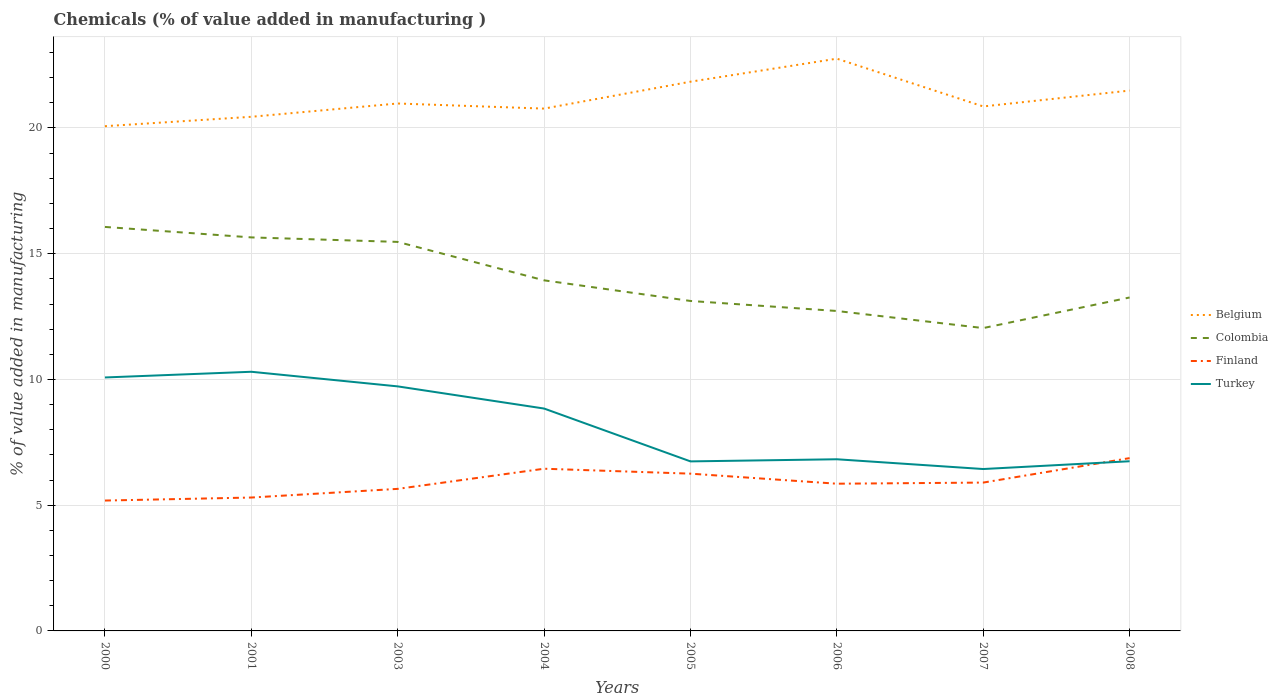How many different coloured lines are there?
Your response must be concise. 4. Does the line corresponding to Belgium intersect with the line corresponding to Turkey?
Provide a succinct answer. No. Across all years, what is the maximum value added in manufacturing chemicals in Belgium?
Keep it short and to the point. 20.07. What is the total value added in manufacturing chemicals in Finland in the graph?
Your response must be concise. -0.62. What is the difference between the highest and the second highest value added in manufacturing chemicals in Finland?
Your answer should be compact. 1.69. What is the difference between the highest and the lowest value added in manufacturing chemicals in Belgium?
Provide a succinct answer. 3. Is the value added in manufacturing chemicals in Belgium strictly greater than the value added in manufacturing chemicals in Turkey over the years?
Make the answer very short. No. How many lines are there?
Make the answer very short. 4. How many years are there in the graph?
Offer a very short reply. 8. Are the values on the major ticks of Y-axis written in scientific E-notation?
Provide a short and direct response. No. Does the graph contain grids?
Offer a terse response. Yes. How many legend labels are there?
Ensure brevity in your answer.  4. What is the title of the graph?
Keep it short and to the point. Chemicals (% of value added in manufacturing ). Does "Israel" appear as one of the legend labels in the graph?
Provide a succinct answer. No. What is the label or title of the X-axis?
Provide a succinct answer. Years. What is the label or title of the Y-axis?
Keep it short and to the point. % of value added in manufacturing. What is the % of value added in manufacturing in Belgium in 2000?
Give a very brief answer. 20.07. What is the % of value added in manufacturing in Colombia in 2000?
Provide a short and direct response. 16.06. What is the % of value added in manufacturing of Finland in 2000?
Your response must be concise. 5.18. What is the % of value added in manufacturing of Turkey in 2000?
Keep it short and to the point. 10.08. What is the % of value added in manufacturing in Belgium in 2001?
Keep it short and to the point. 20.44. What is the % of value added in manufacturing in Colombia in 2001?
Offer a terse response. 15.65. What is the % of value added in manufacturing in Finland in 2001?
Provide a short and direct response. 5.3. What is the % of value added in manufacturing in Turkey in 2001?
Give a very brief answer. 10.31. What is the % of value added in manufacturing of Belgium in 2003?
Offer a terse response. 20.97. What is the % of value added in manufacturing in Colombia in 2003?
Keep it short and to the point. 15.47. What is the % of value added in manufacturing in Finland in 2003?
Ensure brevity in your answer.  5.65. What is the % of value added in manufacturing in Turkey in 2003?
Provide a short and direct response. 9.72. What is the % of value added in manufacturing of Belgium in 2004?
Make the answer very short. 20.77. What is the % of value added in manufacturing of Colombia in 2004?
Offer a terse response. 13.94. What is the % of value added in manufacturing in Finland in 2004?
Your answer should be compact. 6.45. What is the % of value added in manufacturing of Turkey in 2004?
Your answer should be very brief. 8.84. What is the % of value added in manufacturing of Belgium in 2005?
Offer a terse response. 21.84. What is the % of value added in manufacturing of Colombia in 2005?
Your answer should be very brief. 13.12. What is the % of value added in manufacturing in Finland in 2005?
Offer a very short reply. 6.25. What is the % of value added in manufacturing in Turkey in 2005?
Offer a terse response. 6.74. What is the % of value added in manufacturing in Belgium in 2006?
Make the answer very short. 22.76. What is the % of value added in manufacturing of Colombia in 2006?
Your answer should be compact. 12.72. What is the % of value added in manufacturing of Finland in 2006?
Your answer should be very brief. 5.85. What is the % of value added in manufacturing of Turkey in 2006?
Keep it short and to the point. 6.83. What is the % of value added in manufacturing of Belgium in 2007?
Ensure brevity in your answer.  20.86. What is the % of value added in manufacturing in Colombia in 2007?
Provide a short and direct response. 12.04. What is the % of value added in manufacturing of Finland in 2007?
Provide a short and direct response. 5.9. What is the % of value added in manufacturing of Turkey in 2007?
Provide a succinct answer. 6.44. What is the % of value added in manufacturing in Belgium in 2008?
Your answer should be very brief. 21.49. What is the % of value added in manufacturing of Colombia in 2008?
Your answer should be very brief. 13.26. What is the % of value added in manufacturing in Finland in 2008?
Your answer should be compact. 6.87. What is the % of value added in manufacturing of Turkey in 2008?
Keep it short and to the point. 6.75. Across all years, what is the maximum % of value added in manufacturing of Belgium?
Your answer should be very brief. 22.76. Across all years, what is the maximum % of value added in manufacturing in Colombia?
Your response must be concise. 16.06. Across all years, what is the maximum % of value added in manufacturing in Finland?
Your answer should be very brief. 6.87. Across all years, what is the maximum % of value added in manufacturing in Turkey?
Provide a succinct answer. 10.31. Across all years, what is the minimum % of value added in manufacturing in Belgium?
Provide a short and direct response. 20.07. Across all years, what is the minimum % of value added in manufacturing in Colombia?
Provide a succinct answer. 12.04. Across all years, what is the minimum % of value added in manufacturing of Finland?
Ensure brevity in your answer.  5.18. Across all years, what is the minimum % of value added in manufacturing of Turkey?
Provide a succinct answer. 6.44. What is the total % of value added in manufacturing of Belgium in the graph?
Your answer should be very brief. 169.2. What is the total % of value added in manufacturing in Colombia in the graph?
Offer a terse response. 112.27. What is the total % of value added in manufacturing of Finland in the graph?
Make the answer very short. 47.47. What is the total % of value added in manufacturing of Turkey in the graph?
Provide a succinct answer. 65.7. What is the difference between the % of value added in manufacturing in Belgium in 2000 and that in 2001?
Your answer should be compact. -0.37. What is the difference between the % of value added in manufacturing in Colombia in 2000 and that in 2001?
Make the answer very short. 0.42. What is the difference between the % of value added in manufacturing of Finland in 2000 and that in 2001?
Make the answer very short. -0.12. What is the difference between the % of value added in manufacturing in Turkey in 2000 and that in 2001?
Offer a terse response. -0.23. What is the difference between the % of value added in manufacturing of Belgium in 2000 and that in 2003?
Offer a terse response. -0.9. What is the difference between the % of value added in manufacturing in Colombia in 2000 and that in 2003?
Make the answer very short. 0.6. What is the difference between the % of value added in manufacturing in Finland in 2000 and that in 2003?
Keep it short and to the point. -0.46. What is the difference between the % of value added in manufacturing in Turkey in 2000 and that in 2003?
Ensure brevity in your answer.  0.35. What is the difference between the % of value added in manufacturing in Belgium in 2000 and that in 2004?
Make the answer very short. -0.7. What is the difference between the % of value added in manufacturing of Colombia in 2000 and that in 2004?
Provide a short and direct response. 2.12. What is the difference between the % of value added in manufacturing of Finland in 2000 and that in 2004?
Make the answer very short. -1.27. What is the difference between the % of value added in manufacturing of Turkey in 2000 and that in 2004?
Offer a terse response. 1.24. What is the difference between the % of value added in manufacturing of Belgium in 2000 and that in 2005?
Provide a succinct answer. -1.77. What is the difference between the % of value added in manufacturing of Colombia in 2000 and that in 2005?
Offer a terse response. 2.94. What is the difference between the % of value added in manufacturing in Finland in 2000 and that in 2005?
Offer a very short reply. -1.07. What is the difference between the % of value added in manufacturing in Turkey in 2000 and that in 2005?
Your answer should be compact. 3.34. What is the difference between the % of value added in manufacturing of Belgium in 2000 and that in 2006?
Your answer should be compact. -2.68. What is the difference between the % of value added in manufacturing in Colombia in 2000 and that in 2006?
Provide a succinct answer. 3.34. What is the difference between the % of value added in manufacturing of Finland in 2000 and that in 2006?
Your answer should be very brief. -0.67. What is the difference between the % of value added in manufacturing in Turkey in 2000 and that in 2006?
Make the answer very short. 3.25. What is the difference between the % of value added in manufacturing of Belgium in 2000 and that in 2007?
Your answer should be compact. -0.79. What is the difference between the % of value added in manufacturing of Colombia in 2000 and that in 2007?
Provide a succinct answer. 4.02. What is the difference between the % of value added in manufacturing of Finland in 2000 and that in 2007?
Give a very brief answer. -0.71. What is the difference between the % of value added in manufacturing in Turkey in 2000 and that in 2007?
Your answer should be very brief. 3.64. What is the difference between the % of value added in manufacturing of Belgium in 2000 and that in 2008?
Provide a short and direct response. -1.42. What is the difference between the % of value added in manufacturing of Colombia in 2000 and that in 2008?
Ensure brevity in your answer.  2.81. What is the difference between the % of value added in manufacturing of Finland in 2000 and that in 2008?
Provide a short and direct response. -1.69. What is the difference between the % of value added in manufacturing of Turkey in 2000 and that in 2008?
Give a very brief answer. 3.33. What is the difference between the % of value added in manufacturing in Belgium in 2001 and that in 2003?
Ensure brevity in your answer.  -0.53. What is the difference between the % of value added in manufacturing in Colombia in 2001 and that in 2003?
Offer a very short reply. 0.18. What is the difference between the % of value added in manufacturing in Finland in 2001 and that in 2003?
Offer a terse response. -0.34. What is the difference between the % of value added in manufacturing in Turkey in 2001 and that in 2003?
Offer a terse response. 0.58. What is the difference between the % of value added in manufacturing in Belgium in 2001 and that in 2004?
Make the answer very short. -0.33. What is the difference between the % of value added in manufacturing of Colombia in 2001 and that in 2004?
Make the answer very short. 1.71. What is the difference between the % of value added in manufacturing in Finland in 2001 and that in 2004?
Offer a very short reply. -1.15. What is the difference between the % of value added in manufacturing of Turkey in 2001 and that in 2004?
Provide a short and direct response. 1.46. What is the difference between the % of value added in manufacturing in Belgium in 2001 and that in 2005?
Your answer should be very brief. -1.4. What is the difference between the % of value added in manufacturing of Colombia in 2001 and that in 2005?
Provide a succinct answer. 2.53. What is the difference between the % of value added in manufacturing of Finland in 2001 and that in 2005?
Make the answer very short. -0.95. What is the difference between the % of value added in manufacturing of Turkey in 2001 and that in 2005?
Provide a succinct answer. 3.56. What is the difference between the % of value added in manufacturing in Belgium in 2001 and that in 2006?
Your response must be concise. -2.31. What is the difference between the % of value added in manufacturing of Colombia in 2001 and that in 2006?
Provide a succinct answer. 2.93. What is the difference between the % of value added in manufacturing in Finland in 2001 and that in 2006?
Provide a succinct answer. -0.55. What is the difference between the % of value added in manufacturing in Turkey in 2001 and that in 2006?
Ensure brevity in your answer.  3.48. What is the difference between the % of value added in manufacturing of Belgium in 2001 and that in 2007?
Provide a succinct answer. -0.41. What is the difference between the % of value added in manufacturing in Colombia in 2001 and that in 2007?
Provide a short and direct response. 3.61. What is the difference between the % of value added in manufacturing of Finland in 2001 and that in 2007?
Ensure brevity in your answer.  -0.59. What is the difference between the % of value added in manufacturing in Turkey in 2001 and that in 2007?
Give a very brief answer. 3.87. What is the difference between the % of value added in manufacturing of Belgium in 2001 and that in 2008?
Offer a terse response. -1.04. What is the difference between the % of value added in manufacturing of Colombia in 2001 and that in 2008?
Offer a very short reply. 2.39. What is the difference between the % of value added in manufacturing in Finland in 2001 and that in 2008?
Provide a short and direct response. -1.57. What is the difference between the % of value added in manufacturing in Turkey in 2001 and that in 2008?
Provide a short and direct response. 3.56. What is the difference between the % of value added in manufacturing of Belgium in 2003 and that in 2004?
Provide a short and direct response. 0.2. What is the difference between the % of value added in manufacturing in Colombia in 2003 and that in 2004?
Make the answer very short. 1.53. What is the difference between the % of value added in manufacturing in Finland in 2003 and that in 2004?
Offer a very short reply. -0.8. What is the difference between the % of value added in manufacturing in Turkey in 2003 and that in 2004?
Offer a very short reply. 0.88. What is the difference between the % of value added in manufacturing of Belgium in 2003 and that in 2005?
Your response must be concise. -0.87. What is the difference between the % of value added in manufacturing in Colombia in 2003 and that in 2005?
Offer a very short reply. 2.35. What is the difference between the % of value added in manufacturing in Finland in 2003 and that in 2005?
Give a very brief answer. -0.6. What is the difference between the % of value added in manufacturing in Turkey in 2003 and that in 2005?
Your response must be concise. 2.98. What is the difference between the % of value added in manufacturing of Belgium in 2003 and that in 2006?
Keep it short and to the point. -1.78. What is the difference between the % of value added in manufacturing of Colombia in 2003 and that in 2006?
Your answer should be compact. 2.75. What is the difference between the % of value added in manufacturing of Finland in 2003 and that in 2006?
Offer a terse response. -0.2. What is the difference between the % of value added in manufacturing in Turkey in 2003 and that in 2006?
Your answer should be compact. 2.9. What is the difference between the % of value added in manufacturing of Belgium in 2003 and that in 2007?
Your response must be concise. 0.12. What is the difference between the % of value added in manufacturing in Colombia in 2003 and that in 2007?
Make the answer very short. 3.43. What is the difference between the % of value added in manufacturing of Finland in 2003 and that in 2007?
Make the answer very short. -0.25. What is the difference between the % of value added in manufacturing of Turkey in 2003 and that in 2007?
Ensure brevity in your answer.  3.29. What is the difference between the % of value added in manufacturing of Belgium in 2003 and that in 2008?
Offer a terse response. -0.51. What is the difference between the % of value added in manufacturing of Colombia in 2003 and that in 2008?
Ensure brevity in your answer.  2.21. What is the difference between the % of value added in manufacturing of Finland in 2003 and that in 2008?
Keep it short and to the point. -1.22. What is the difference between the % of value added in manufacturing of Turkey in 2003 and that in 2008?
Your response must be concise. 2.98. What is the difference between the % of value added in manufacturing of Belgium in 2004 and that in 2005?
Your response must be concise. -1.07. What is the difference between the % of value added in manufacturing of Colombia in 2004 and that in 2005?
Your response must be concise. 0.82. What is the difference between the % of value added in manufacturing in Finland in 2004 and that in 2005?
Provide a succinct answer. 0.2. What is the difference between the % of value added in manufacturing in Turkey in 2004 and that in 2005?
Your response must be concise. 2.1. What is the difference between the % of value added in manufacturing of Belgium in 2004 and that in 2006?
Make the answer very short. -1.99. What is the difference between the % of value added in manufacturing of Colombia in 2004 and that in 2006?
Ensure brevity in your answer.  1.22. What is the difference between the % of value added in manufacturing of Finland in 2004 and that in 2006?
Offer a terse response. 0.6. What is the difference between the % of value added in manufacturing of Turkey in 2004 and that in 2006?
Your answer should be compact. 2.02. What is the difference between the % of value added in manufacturing of Belgium in 2004 and that in 2007?
Your answer should be very brief. -0.09. What is the difference between the % of value added in manufacturing in Colombia in 2004 and that in 2007?
Ensure brevity in your answer.  1.9. What is the difference between the % of value added in manufacturing of Finland in 2004 and that in 2007?
Keep it short and to the point. 0.55. What is the difference between the % of value added in manufacturing in Turkey in 2004 and that in 2007?
Give a very brief answer. 2.41. What is the difference between the % of value added in manufacturing of Belgium in 2004 and that in 2008?
Keep it short and to the point. -0.72. What is the difference between the % of value added in manufacturing of Colombia in 2004 and that in 2008?
Offer a very short reply. 0.68. What is the difference between the % of value added in manufacturing in Finland in 2004 and that in 2008?
Provide a succinct answer. -0.42. What is the difference between the % of value added in manufacturing of Turkey in 2004 and that in 2008?
Your answer should be very brief. 2.1. What is the difference between the % of value added in manufacturing of Belgium in 2005 and that in 2006?
Your answer should be very brief. -0.92. What is the difference between the % of value added in manufacturing in Colombia in 2005 and that in 2006?
Your answer should be compact. 0.4. What is the difference between the % of value added in manufacturing of Finland in 2005 and that in 2006?
Your response must be concise. 0.4. What is the difference between the % of value added in manufacturing in Turkey in 2005 and that in 2006?
Provide a succinct answer. -0.08. What is the difference between the % of value added in manufacturing of Belgium in 2005 and that in 2007?
Offer a very short reply. 0.98. What is the difference between the % of value added in manufacturing of Colombia in 2005 and that in 2007?
Ensure brevity in your answer.  1.08. What is the difference between the % of value added in manufacturing of Finland in 2005 and that in 2007?
Give a very brief answer. 0.35. What is the difference between the % of value added in manufacturing in Turkey in 2005 and that in 2007?
Ensure brevity in your answer.  0.3. What is the difference between the % of value added in manufacturing of Belgium in 2005 and that in 2008?
Offer a very short reply. 0.35. What is the difference between the % of value added in manufacturing in Colombia in 2005 and that in 2008?
Give a very brief answer. -0.14. What is the difference between the % of value added in manufacturing in Finland in 2005 and that in 2008?
Provide a succinct answer. -0.62. What is the difference between the % of value added in manufacturing of Turkey in 2005 and that in 2008?
Offer a very short reply. -0.01. What is the difference between the % of value added in manufacturing of Belgium in 2006 and that in 2007?
Your response must be concise. 1.9. What is the difference between the % of value added in manufacturing of Colombia in 2006 and that in 2007?
Ensure brevity in your answer.  0.68. What is the difference between the % of value added in manufacturing of Finland in 2006 and that in 2007?
Offer a terse response. -0.05. What is the difference between the % of value added in manufacturing in Turkey in 2006 and that in 2007?
Offer a terse response. 0.39. What is the difference between the % of value added in manufacturing of Belgium in 2006 and that in 2008?
Offer a terse response. 1.27. What is the difference between the % of value added in manufacturing of Colombia in 2006 and that in 2008?
Provide a short and direct response. -0.54. What is the difference between the % of value added in manufacturing in Finland in 2006 and that in 2008?
Offer a terse response. -1.02. What is the difference between the % of value added in manufacturing in Turkey in 2006 and that in 2008?
Keep it short and to the point. 0.08. What is the difference between the % of value added in manufacturing of Belgium in 2007 and that in 2008?
Give a very brief answer. -0.63. What is the difference between the % of value added in manufacturing in Colombia in 2007 and that in 2008?
Keep it short and to the point. -1.22. What is the difference between the % of value added in manufacturing in Finland in 2007 and that in 2008?
Give a very brief answer. -0.97. What is the difference between the % of value added in manufacturing of Turkey in 2007 and that in 2008?
Your answer should be compact. -0.31. What is the difference between the % of value added in manufacturing of Belgium in 2000 and the % of value added in manufacturing of Colombia in 2001?
Offer a very short reply. 4.42. What is the difference between the % of value added in manufacturing in Belgium in 2000 and the % of value added in manufacturing in Finland in 2001?
Offer a terse response. 14.77. What is the difference between the % of value added in manufacturing of Belgium in 2000 and the % of value added in manufacturing of Turkey in 2001?
Your answer should be compact. 9.77. What is the difference between the % of value added in manufacturing of Colombia in 2000 and the % of value added in manufacturing of Finland in 2001?
Offer a terse response. 10.76. What is the difference between the % of value added in manufacturing in Colombia in 2000 and the % of value added in manufacturing in Turkey in 2001?
Your answer should be very brief. 5.76. What is the difference between the % of value added in manufacturing in Finland in 2000 and the % of value added in manufacturing in Turkey in 2001?
Make the answer very short. -5.12. What is the difference between the % of value added in manufacturing of Belgium in 2000 and the % of value added in manufacturing of Colombia in 2003?
Provide a short and direct response. 4.6. What is the difference between the % of value added in manufacturing of Belgium in 2000 and the % of value added in manufacturing of Finland in 2003?
Make the answer very short. 14.42. What is the difference between the % of value added in manufacturing of Belgium in 2000 and the % of value added in manufacturing of Turkey in 2003?
Give a very brief answer. 10.35. What is the difference between the % of value added in manufacturing in Colombia in 2000 and the % of value added in manufacturing in Finland in 2003?
Offer a very short reply. 10.42. What is the difference between the % of value added in manufacturing in Colombia in 2000 and the % of value added in manufacturing in Turkey in 2003?
Your answer should be very brief. 6.34. What is the difference between the % of value added in manufacturing in Finland in 2000 and the % of value added in manufacturing in Turkey in 2003?
Your response must be concise. -4.54. What is the difference between the % of value added in manufacturing of Belgium in 2000 and the % of value added in manufacturing of Colombia in 2004?
Your response must be concise. 6.13. What is the difference between the % of value added in manufacturing in Belgium in 2000 and the % of value added in manufacturing in Finland in 2004?
Your response must be concise. 13.62. What is the difference between the % of value added in manufacturing in Belgium in 2000 and the % of value added in manufacturing in Turkey in 2004?
Offer a very short reply. 11.23. What is the difference between the % of value added in manufacturing of Colombia in 2000 and the % of value added in manufacturing of Finland in 2004?
Keep it short and to the point. 9.61. What is the difference between the % of value added in manufacturing of Colombia in 2000 and the % of value added in manufacturing of Turkey in 2004?
Ensure brevity in your answer.  7.22. What is the difference between the % of value added in manufacturing in Finland in 2000 and the % of value added in manufacturing in Turkey in 2004?
Offer a terse response. -3.66. What is the difference between the % of value added in manufacturing of Belgium in 2000 and the % of value added in manufacturing of Colombia in 2005?
Offer a very short reply. 6.95. What is the difference between the % of value added in manufacturing in Belgium in 2000 and the % of value added in manufacturing in Finland in 2005?
Provide a succinct answer. 13.82. What is the difference between the % of value added in manufacturing in Belgium in 2000 and the % of value added in manufacturing in Turkey in 2005?
Ensure brevity in your answer.  13.33. What is the difference between the % of value added in manufacturing of Colombia in 2000 and the % of value added in manufacturing of Finland in 2005?
Your answer should be compact. 9.81. What is the difference between the % of value added in manufacturing of Colombia in 2000 and the % of value added in manufacturing of Turkey in 2005?
Offer a very short reply. 9.32. What is the difference between the % of value added in manufacturing in Finland in 2000 and the % of value added in manufacturing in Turkey in 2005?
Make the answer very short. -1.56. What is the difference between the % of value added in manufacturing of Belgium in 2000 and the % of value added in manufacturing of Colombia in 2006?
Offer a terse response. 7.35. What is the difference between the % of value added in manufacturing of Belgium in 2000 and the % of value added in manufacturing of Finland in 2006?
Your answer should be very brief. 14.22. What is the difference between the % of value added in manufacturing in Belgium in 2000 and the % of value added in manufacturing in Turkey in 2006?
Keep it short and to the point. 13.24. What is the difference between the % of value added in manufacturing of Colombia in 2000 and the % of value added in manufacturing of Finland in 2006?
Provide a short and direct response. 10.21. What is the difference between the % of value added in manufacturing in Colombia in 2000 and the % of value added in manufacturing in Turkey in 2006?
Make the answer very short. 9.24. What is the difference between the % of value added in manufacturing of Finland in 2000 and the % of value added in manufacturing of Turkey in 2006?
Give a very brief answer. -1.64. What is the difference between the % of value added in manufacturing in Belgium in 2000 and the % of value added in manufacturing in Colombia in 2007?
Your answer should be compact. 8.03. What is the difference between the % of value added in manufacturing in Belgium in 2000 and the % of value added in manufacturing in Finland in 2007?
Ensure brevity in your answer.  14.17. What is the difference between the % of value added in manufacturing in Belgium in 2000 and the % of value added in manufacturing in Turkey in 2007?
Ensure brevity in your answer.  13.63. What is the difference between the % of value added in manufacturing of Colombia in 2000 and the % of value added in manufacturing of Finland in 2007?
Provide a short and direct response. 10.17. What is the difference between the % of value added in manufacturing of Colombia in 2000 and the % of value added in manufacturing of Turkey in 2007?
Offer a very short reply. 9.63. What is the difference between the % of value added in manufacturing in Finland in 2000 and the % of value added in manufacturing in Turkey in 2007?
Keep it short and to the point. -1.25. What is the difference between the % of value added in manufacturing in Belgium in 2000 and the % of value added in manufacturing in Colombia in 2008?
Ensure brevity in your answer.  6.81. What is the difference between the % of value added in manufacturing in Belgium in 2000 and the % of value added in manufacturing in Finland in 2008?
Offer a terse response. 13.2. What is the difference between the % of value added in manufacturing of Belgium in 2000 and the % of value added in manufacturing of Turkey in 2008?
Provide a short and direct response. 13.32. What is the difference between the % of value added in manufacturing of Colombia in 2000 and the % of value added in manufacturing of Finland in 2008?
Provide a short and direct response. 9.19. What is the difference between the % of value added in manufacturing in Colombia in 2000 and the % of value added in manufacturing in Turkey in 2008?
Your response must be concise. 9.32. What is the difference between the % of value added in manufacturing in Finland in 2000 and the % of value added in manufacturing in Turkey in 2008?
Offer a very short reply. -1.56. What is the difference between the % of value added in manufacturing of Belgium in 2001 and the % of value added in manufacturing of Colombia in 2003?
Ensure brevity in your answer.  4.97. What is the difference between the % of value added in manufacturing in Belgium in 2001 and the % of value added in manufacturing in Finland in 2003?
Ensure brevity in your answer.  14.8. What is the difference between the % of value added in manufacturing of Belgium in 2001 and the % of value added in manufacturing of Turkey in 2003?
Ensure brevity in your answer.  10.72. What is the difference between the % of value added in manufacturing in Colombia in 2001 and the % of value added in manufacturing in Finland in 2003?
Provide a succinct answer. 10. What is the difference between the % of value added in manufacturing of Colombia in 2001 and the % of value added in manufacturing of Turkey in 2003?
Ensure brevity in your answer.  5.92. What is the difference between the % of value added in manufacturing in Finland in 2001 and the % of value added in manufacturing in Turkey in 2003?
Your response must be concise. -4.42. What is the difference between the % of value added in manufacturing of Belgium in 2001 and the % of value added in manufacturing of Colombia in 2004?
Ensure brevity in your answer.  6.5. What is the difference between the % of value added in manufacturing in Belgium in 2001 and the % of value added in manufacturing in Finland in 2004?
Offer a very short reply. 13.99. What is the difference between the % of value added in manufacturing of Belgium in 2001 and the % of value added in manufacturing of Turkey in 2004?
Provide a short and direct response. 11.6. What is the difference between the % of value added in manufacturing in Colombia in 2001 and the % of value added in manufacturing in Finland in 2004?
Offer a very short reply. 9.2. What is the difference between the % of value added in manufacturing of Colombia in 2001 and the % of value added in manufacturing of Turkey in 2004?
Provide a short and direct response. 6.81. What is the difference between the % of value added in manufacturing of Finland in 2001 and the % of value added in manufacturing of Turkey in 2004?
Offer a terse response. -3.54. What is the difference between the % of value added in manufacturing of Belgium in 2001 and the % of value added in manufacturing of Colombia in 2005?
Keep it short and to the point. 7.32. What is the difference between the % of value added in manufacturing in Belgium in 2001 and the % of value added in manufacturing in Finland in 2005?
Provide a succinct answer. 14.19. What is the difference between the % of value added in manufacturing in Belgium in 2001 and the % of value added in manufacturing in Turkey in 2005?
Your answer should be very brief. 13.7. What is the difference between the % of value added in manufacturing of Colombia in 2001 and the % of value added in manufacturing of Finland in 2005?
Keep it short and to the point. 9.39. What is the difference between the % of value added in manufacturing in Colombia in 2001 and the % of value added in manufacturing in Turkey in 2005?
Provide a short and direct response. 8.91. What is the difference between the % of value added in manufacturing of Finland in 2001 and the % of value added in manufacturing of Turkey in 2005?
Your response must be concise. -1.44. What is the difference between the % of value added in manufacturing of Belgium in 2001 and the % of value added in manufacturing of Colombia in 2006?
Ensure brevity in your answer.  7.72. What is the difference between the % of value added in manufacturing of Belgium in 2001 and the % of value added in manufacturing of Finland in 2006?
Keep it short and to the point. 14.59. What is the difference between the % of value added in manufacturing in Belgium in 2001 and the % of value added in manufacturing in Turkey in 2006?
Provide a succinct answer. 13.62. What is the difference between the % of value added in manufacturing in Colombia in 2001 and the % of value added in manufacturing in Finland in 2006?
Offer a terse response. 9.79. What is the difference between the % of value added in manufacturing in Colombia in 2001 and the % of value added in manufacturing in Turkey in 2006?
Keep it short and to the point. 8.82. What is the difference between the % of value added in manufacturing of Finland in 2001 and the % of value added in manufacturing of Turkey in 2006?
Provide a succinct answer. -1.52. What is the difference between the % of value added in manufacturing in Belgium in 2001 and the % of value added in manufacturing in Colombia in 2007?
Your response must be concise. 8.4. What is the difference between the % of value added in manufacturing in Belgium in 2001 and the % of value added in manufacturing in Finland in 2007?
Provide a short and direct response. 14.55. What is the difference between the % of value added in manufacturing of Belgium in 2001 and the % of value added in manufacturing of Turkey in 2007?
Your response must be concise. 14.01. What is the difference between the % of value added in manufacturing of Colombia in 2001 and the % of value added in manufacturing of Finland in 2007?
Provide a succinct answer. 9.75. What is the difference between the % of value added in manufacturing in Colombia in 2001 and the % of value added in manufacturing in Turkey in 2007?
Offer a terse response. 9.21. What is the difference between the % of value added in manufacturing of Finland in 2001 and the % of value added in manufacturing of Turkey in 2007?
Keep it short and to the point. -1.13. What is the difference between the % of value added in manufacturing in Belgium in 2001 and the % of value added in manufacturing in Colombia in 2008?
Keep it short and to the point. 7.19. What is the difference between the % of value added in manufacturing in Belgium in 2001 and the % of value added in manufacturing in Finland in 2008?
Your response must be concise. 13.57. What is the difference between the % of value added in manufacturing of Belgium in 2001 and the % of value added in manufacturing of Turkey in 2008?
Keep it short and to the point. 13.7. What is the difference between the % of value added in manufacturing in Colombia in 2001 and the % of value added in manufacturing in Finland in 2008?
Keep it short and to the point. 8.78. What is the difference between the % of value added in manufacturing of Colombia in 2001 and the % of value added in manufacturing of Turkey in 2008?
Offer a terse response. 8.9. What is the difference between the % of value added in manufacturing of Finland in 2001 and the % of value added in manufacturing of Turkey in 2008?
Give a very brief answer. -1.44. What is the difference between the % of value added in manufacturing in Belgium in 2003 and the % of value added in manufacturing in Colombia in 2004?
Offer a very short reply. 7.03. What is the difference between the % of value added in manufacturing of Belgium in 2003 and the % of value added in manufacturing of Finland in 2004?
Provide a succinct answer. 14.52. What is the difference between the % of value added in manufacturing in Belgium in 2003 and the % of value added in manufacturing in Turkey in 2004?
Provide a short and direct response. 12.13. What is the difference between the % of value added in manufacturing of Colombia in 2003 and the % of value added in manufacturing of Finland in 2004?
Offer a very short reply. 9.02. What is the difference between the % of value added in manufacturing in Colombia in 2003 and the % of value added in manufacturing in Turkey in 2004?
Provide a short and direct response. 6.63. What is the difference between the % of value added in manufacturing of Finland in 2003 and the % of value added in manufacturing of Turkey in 2004?
Provide a short and direct response. -3.19. What is the difference between the % of value added in manufacturing of Belgium in 2003 and the % of value added in manufacturing of Colombia in 2005?
Offer a very short reply. 7.85. What is the difference between the % of value added in manufacturing of Belgium in 2003 and the % of value added in manufacturing of Finland in 2005?
Your answer should be very brief. 14.72. What is the difference between the % of value added in manufacturing of Belgium in 2003 and the % of value added in manufacturing of Turkey in 2005?
Offer a terse response. 14.23. What is the difference between the % of value added in manufacturing of Colombia in 2003 and the % of value added in manufacturing of Finland in 2005?
Keep it short and to the point. 9.22. What is the difference between the % of value added in manufacturing in Colombia in 2003 and the % of value added in manufacturing in Turkey in 2005?
Ensure brevity in your answer.  8.73. What is the difference between the % of value added in manufacturing in Finland in 2003 and the % of value added in manufacturing in Turkey in 2005?
Provide a short and direct response. -1.09. What is the difference between the % of value added in manufacturing in Belgium in 2003 and the % of value added in manufacturing in Colombia in 2006?
Make the answer very short. 8.25. What is the difference between the % of value added in manufacturing in Belgium in 2003 and the % of value added in manufacturing in Finland in 2006?
Offer a terse response. 15.12. What is the difference between the % of value added in manufacturing in Belgium in 2003 and the % of value added in manufacturing in Turkey in 2006?
Ensure brevity in your answer.  14.15. What is the difference between the % of value added in manufacturing of Colombia in 2003 and the % of value added in manufacturing of Finland in 2006?
Give a very brief answer. 9.62. What is the difference between the % of value added in manufacturing of Colombia in 2003 and the % of value added in manufacturing of Turkey in 2006?
Your answer should be compact. 8.64. What is the difference between the % of value added in manufacturing of Finland in 2003 and the % of value added in manufacturing of Turkey in 2006?
Offer a very short reply. -1.18. What is the difference between the % of value added in manufacturing of Belgium in 2003 and the % of value added in manufacturing of Colombia in 2007?
Your answer should be very brief. 8.93. What is the difference between the % of value added in manufacturing in Belgium in 2003 and the % of value added in manufacturing in Finland in 2007?
Your answer should be very brief. 15.07. What is the difference between the % of value added in manufacturing in Belgium in 2003 and the % of value added in manufacturing in Turkey in 2007?
Your answer should be very brief. 14.54. What is the difference between the % of value added in manufacturing of Colombia in 2003 and the % of value added in manufacturing of Finland in 2007?
Provide a succinct answer. 9.57. What is the difference between the % of value added in manufacturing in Colombia in 2003 and the % of value added in manufacturing in Turkey in 2007?
Offer a very short reply. 9.03. What is the difference between the % of value added in manufacturing of Finland in 2003 and the % of value added in manufacturing of Turkey in 2007?
Offer a very short reply. -0.79. What is the difference between the % of value added in manufacturing of Belgium in 2003 and the % of value added in manufacturing of Colombia in 2008?
Give a very brief answer. 7.71. What is the difference between the % of value added in manufacturing of Belgium in 2003 and the % of value added in manufacturing of Finland in 2008?
Offer a terse response. 14.1. What is the difference between the % of value added in manufacturing of Belgium in 2003 and the % of value added in manufacturing of Turkey in 2008?
Make the answer very short. 14.23. What is the difference between the % of value added in manufacturing of Colombia in 2003 and the % of value added in manufacturing of Finland in 2008?
Offer a terse response. 8.6. What is the difference between the % of value added in manufacturing in Colombia in 2003 and the % of value added in manufacturing in Turkey in 2008?
Provide a short and direct response. 8.72. What is the difference between the % of value added in manufacturing in Finland in 2003 and the % of value added in manufacturing in Turkey in 2008?
Your answer should be compact. -1.1. What is the difference between the % of value added in manufacturing in Belgium in 2004 and the % of value added in manufacturing in Colombia in 2005?
Your answer should be compact. 7.65. What is the difference between the % of value added in manufacturing of Belgium in 2004 and the % of value added in manufacturing of Finland in 2005?
Offer a terse response. 14.52. What is the difference between the % of value added in manufacturing of Belgium in 2004 and the % of value added in manufacturing of Turkey in 2005?
Keep it short and to the point. 14.03. What is the difference between the % of value added in manufacturing of Colombia in 2004 and the % of value added in manufacturing of Finland in 2005?
Provide a succinct answer. 7.69. What is the difference between the % of value added in manufacturing of Colombia in 2004 and the % of value added in manufacturing of Turkey in 2005?
Ensure brevity in your answer.  7.2. What is the difference between the % of value added in manufacturing of Finland in 2004 and the % of value added in manufacturing of Turkey in 2005?
Your response must be concise. -0.29. What is the difference between the % of value added in manufacturing in Belgium in 2004 and the % of value added in manufacturing in Colombia in 2006?
Your answer should be very brief. 8.05. What is the difference between the % of value added in manufacturing of Belgium in 2004 and the % of value added in manufacturing of Finland in 2006?
Your answer should be very brief. 14.92. What is the difference between the % of value added in manufacturing in Belgium in 2004 and the % of value added in manufacturing in Turkey in 2006?
Provide a short and direct response. 13.94. What is the difference between the % of value added in manufacturing in Colombia in 2004 and the % of value added in manufacturing in Finland in 2006?
Provide a succinct answer. 8.09. What is the difference between the % of value added in manufacturing in Colombia in 2004 and the % of value added in manufacturing in Turkey in 2006?
Provide a short and direct response. 7.12. What is the difference between the % of value added in manufacturing in Finland in 2004 and the % of value added in manufacturing in Turkey in 2006?
Offer a very short reply. -0.38. What is the difference between the % of value added in manufacturing in Belgium in 2004 and the % of value added in manufacturing in Colombia in 2007?
Make the answer very short. 8.73. What is the difference between the % of value added in manufacturing in Belgium in 2004 and the % of value added in manufacturing in Finland in 2007?
Your response must be concise. 14.87. What is the difference between the % of value added in manufacturing of Belgium in 2004 and the % of value added in manufacturing of Turkey in 2007?
Give a very brief answer. 14.33. What is the difference between the % of value added in manufacturing of Colombia in 2004 and the % of value added in manufacturing of Finland in 2007?
Provide a succinct answer. 8.04. What is the difference between the % of value added in manufacturing in Colombia in 2004 and the % of value added in manufacturing in Turkey in 2007?
Offer a terse response. 7.5. What is the difference between the % of value added in manufacturing of Finland in 2004 and the % of value added in manufacturing of Turkey in 2007?
Keep it short and to the point. 0.01. What is the difference between the % of value added in manufacturing of Belgium in 2004 and the % of value added in manufacturing of Colombia in 2008?
Make the answer very short. 7.51. What is the difference between the % of value added in manufacturing in Belgium in 2004 and the % of value added in manufacturing in Finland in 2008?
Your answer should be very brief. 13.9. What is the difference between the % of value added in manufacturing in Belgium in 2004 and the % of value added in manufacturing in Turkey in 2008?
Make the answer very short. 14.02. What is the difference between the % of value added in manufacturing of Colombia in 2004 and the % of value added in manufacturing of Finland in 2008?
Offer a terse response. 7.07. What is the difference between the % of value added in manufacturing of Colombia in 2004 and the % of value added in manufacturing of Turkey in 2008?
Make the answer very short. 7.19. What is the difference between the % of value added in manufacturing of Finland in 2004 and the % of value added in manufacturing of Turkey in 2008?
Provide a succinct answer. -0.3. What is the difference between the % of value added in manufacturing in Belgium in 2005 and the % of value added in manufacturing in Colombia in 2006?
Give a very brief answer. 9.12. What is the difference between the % of value added in manufacturing in Belgium in 2005 and the % of value added in manufacturing in Finland in 2006?
Ensure brevity in your answer.  15.99. What is the difference between the % of value added in manufacturing of Belgium in 2005 and the % of value added in manufacturing of Turkey in 2006?
Keep it short and to the point. 15.01. What is the difference between the % of value added in manufacturing of Colombia in 2005 and the % of value added in manufacturing of Finland in 2006?
Provide a short and direct response. 7.27. What is the difference between the % of value added in manufacturing in Colombia in 2005 and the % of value added in manufacturing in Turkey in 2006?
Your answer should be compact. 6.29. What is the difference between the % of value added in manufacturing in Finland in 2005 and the % of value added in manufacturing in Turkey in 2006?
Offer a very short reply. -0.57. What is the difference between the % of value added in manufacturing of Belgium in 2005 and the % of value added in manufacturing of Colombia in 2007?
Offer a terse response. 9.8. What is the difference between the % of value added in manufacturing of Belgium in 2005 and the % of value added in manufacturing of Finland in 2007?
Ensure brevity in your answer.  15.94. What is the difference between the % of value added in manufacturing in Belgium in 2005 and the % of value added in manufacturing in Turkey in 2007?
Keep it short and to the point. 15.4. What is the difference between the % of value added in manufacturing in Colombia in 2005 and the % of value added in manufacturing in Finland in 2007?
Ensure brevity in your answer.  7.22. What is the difference between the % of value added in manufacturing in Colombia in 2005 and the % of value added in manufacturing in Turkey in 2007?
Your response must be concise. 6.68. What is the difference between the % of value added in manufacturing of Finland in 2005 and the % of value added in manufacturing of Turkey in 2007?
Keep it short and to the point. -0.18. What is the difference between the % of value added in manufacturing of Belgium in 2005 and the % of value added in manufacturing of Colombia in 2008?
Offer a very short reply. 8.58. What is the difference between the % of value added in manufacturing in Belgium in 2005 and the % of value added in manufacturing in Finland in 2008?
Provide a short and direct response. 14.97. What is the difference between the % of value added in manufacturing of Belgium in 2005 and the % of value added in manufacturing of Turkey in 2008?
Keep it short and to the point. 15.09. What is the difference between the % of value added in manufacturing of Colombia in 2005 and the % of value added in manufacturing of Finland in 2008?
Give a very brief answer. 6.25. What is the difference between the % of value added in manufacturing of Colombia in 2005 and the % of value added in manufacturing of Turkey in 2008?
Make the answer very short. 6.37. What is the difference between the % of value added in manufacturing of Finland in 2005 and the % of value added in manufacturing of Turkey in 2008?
Provide a short and direct response. -0.49. What is the difference between the % of value added in manufacturing in Belgium in 2006 and the % of value added in manufacturing in Colombia in 2007?
Your answer should be compact. 10.71. What is the difference between the % of value added in manufacturing in Belgium in 2006 and the % of value added in manufacturing in Finland in 2007?
Your answer should be very brief. 16.86. What is the difference between the % of value added in manufacturing of Belgium in 2006 and the % of value added in manufacturing of Turkey in 2007?
Provide a succinct answer. 16.32. What is the difference between the % of value added in manufacturing in Colombia in 2006 and the % of value added in manufacturing in Finland in 2007?
Provide a short and direct response. 6.82. What is the difference between the % of value added in manufacturing of Colombia in 2006 and the % of value added in manufacturing of Turkey in 2007?
Your answer should be very brief. 6.28. What is the difference between the % of value added in manufacturing in Finland in 2006 and the % of value added in manufacturing in Turkey in 2007?
Give a very brief answer. -0.58. What is the difference between the % of value added in manufacturing in Belgium in 2006 and the % of value added in manufacturing in Colombia in 2008?
Ensure brevity in your answer.  9.5. What is the difference between the % of value added in manufacturing in Belgium in 2006 and the % of value added in manufacturing in Finland in 2008?
Give a very brief answer. 15.88. What is the difference between the % of value added in manufacturing in Belgium in 2006 and the % of value added in manufacturing in Turkey in 2008?
Provide a succinct answer. 16.01. What is the difference between the % of value added in manufacturing of Colombia in 2006 and the % of value added in manufacturing of Finland in 2008?
Keep it short and to the point. 5.85. What is the difference between the % of value added in manufacturing of Colombia in 2006 and the % of value added in manufacturing of Turkey in 2008?
Your answer should be very brief. 5.98. What is the difference between the % of value added in manufacturing in Finland in 2006 and the % of value added in manufacturing in Turkey in 2008?
Give a very brief answer. -0.89. What is the difference between the % of value added in manufacturing in Belgium in 2007 and the % of value added in manufacturing in Colombia in 2008?
Give a very brief answer. 7.6. What is the difference between the % of value added in manufacturing in Belgium in 2007 and the % of value added in manufacturing in Finland in 2008?
Make the answer very short. 13.98. What is the difference between the % of value added in manufacturing of Belgium in 2007 and the % of value added in manufacturing of Turkey in 2008?
Your answer should be very brief. 14.11. What is the difference between the % of value added in manufacturing in Colombia in 2007 and the % of value added in manufacturing in Finland in 2008?
Your answer should be compact. 5.17. What is the difference between the % of value added in manufacturing in Colombia in 2007 and the % of value added in manufacturing in Turkey in 2008?
Keep it short and to the point. 5.3. What is the difference between the % of value added in manufacturing in Finland in 2007 and the % of value added in manufacturing in Turkey in 2008?
Your answer should be very brief. -0.85. What is the average % of value added in manufacturing in Belgium per year?
Your response must be concise. 21.15. What is the average % of value added in manufacturing of Colombia per year?
Offer a terse response. 14.03. What is the average % of value added in manufacturing of Finland per year?
Give a very brief answer. 5.93. What is the average % of value added in manufacturing in Turkey per year?
Keep it short and to the point. 8.21. In the year 2000, what is the difference between the % of value added in manufacturing of Belgium and % of value added in manufacturing of Colombia?
Offer a very short reply. 4.01. In the year 2000, what is the difference between the % of value added in manufacturing of Belgium and % of value added in manufacturing of Finland?
Provide a succinct answer. 14.89. In the year 2000, what is the difference between the % of value added in manufacturing of Belgium and % of value added in manufacturing of Turkey?
Ensure brevity in your answer.  9.99. In the year 2000, what is the difference between the % of value added in manufacturing of Colombia and % of value added in manufacturing of Finland?
Provide a short and direct response. 10.88. In the year 2000, what is the difference between the % of value added in manufacturing in Colombia and % of value added in manufacturing in Turkey?
Provide a short and direct response. 5.99. In the year 2000, what is the difference between the % of value added in manufacturing of Finland and % of value added in manufacturing of Turkey?
Make the answer very short. -4.89. In the year 2001, what is the difference between the % of value added in manufacturing of Belgium and % of value added in manufacturing of Colombia?
Make the answer very short. 4.8. In the year 2001, what is the difference between the % of value added in manufacturing in Belgium and % of value added in manufacturing in Finland?
Provide a succinct answer. 15.14. In the year 2001, what is the difference between the % of value added in manufacturing in Belgium and % of value added in manufacturing in Turkey?
Give a very brief answer. 10.14. In the year 2001, what is the difference between the % of value added in manufacturing of Colombia and % of value added in manufacturing of Finland?
Make the answer very short. 10.34. In the year 2001, what is the difference between the % of value added in manufacturing in Colombia and % of value added in manufacturing in Turkey?
Offer a very short reply. 5.34. In the year 2001, what is the difference between the % of value added in manufacturing of Finland and % of value added in manufacturing of Turkey?
Keep it short and to the point. -5. In the year 2003, what is the difference between the % of value added in manufacturing in Belgium and % of value added in manufacturing in Colombia?
Give a very brief answer. 5.5. In the year 2003, what is the difference between the % of value added in manufacturing of Belgium and % of value added in manufacturing of Finland?
Give a very brief answer. 15.32. In the year 2003, what is the difference between the % of value added in manufacturing in Belgium and % of value added in manufacturing in Turkey?
Give a very brief answer. 11.25. In the year 2003, what is the difference between the % of value added in manufacturing of Colombia and % of value added in manufacturing of Finland?
Give a very brief answer. 9.82. In the year 2003, what is the difference between the % of value added in manufacturing in Colombia and % of value added in manufacturing in Turkey?
Your response must be concise. 5.75. In the year 2003, what is the difference between the % of value added in manufacturing in Finland and % of value added in manufacturing in Turkey?
Your answer should be very brief. -4.08. In the year 2004, what is the difference between the % of value added in manufacturing of Belgium and % of value added in manufacturing of Colombia?
Keep it short and to the point. 6.83. In the year 2004, what is the difference between the % of value added in manufacturing in Belgium and % of value added in manufacturing in Finland?
Your answer should be compact. 14.32. In the year 2004, what is the difference between the % of value added in manufacturing in Belgium and % of value added in manufacturing in Turkey?
Your response must be concise. 11.93. In the year 2004, what is the difference between the % of value added in manufacturing in Colombia and % of value added in manufacturing in Finland?
Offer a very short reply. 7.49. In the year 2004, what is the difference between the % of value added in manufacturing of Colombia and % of value added in manufacturing of Turkey?
Offer a very short reply. 5.1. In the year 2004, what is the difference between the % of value added in manufacturing in Finland and % of value added in manufacturing in Turkey?
Ensure brevity in your answer.  -2.39. In the year 2005, what is the difference between the % of value added in manufacturing of Belgium and % of value added in manufacturing of Colombia?
Your answer should be compact. 8.72. In the year 2005, what is the difference between the % of value added in manufacturing in Belgium and % of value added in manufacturing in Finland?
Your answer should be very brief. 15.59. In the year 2005, what is the difference between the % of value added in manufacturing in Belgium and % of value added in manufacturing in Turkey?
Make the answer very short. 15.1. In the year 2005, what is the difference between the % of value added in manufacturing in Colombia and % of value added in manufacturing in Finland?
Your answer should be very brief. 6.87. In the year 2005, what is the difference between the % of value added in manufacturing in Colombia and % of value added in manufacturing in Turkey?
Offer a very short reply. 6.38. In the year 2005, what is the difference between the % of value added in manufacturing of Finland and % of value added in manufacturing of Turkey?
Offer a very short reply. -0.49. In the year 2006, what is the difference between the % of value added in manufacturing in Belgium and % of value added in manufacturing in Colombia?
Provide a succinct answer. 10.03. In the year 2006, what is the difference between the % of value added in manufacturing in Belgium and % of value added in manufacturing in Finland?
Keep it short and to the point. 16.9. In the year 2006, what is the difference between the % of value added in manufacturing in Belgium and % of value added in manufacturing in Turkey?
Your answer should be very brief. 15.93. In the year 2006, what is the difference between the % of value added in manufacturing of Colombia and % of value added in manufacturing of Finland?
Ensure brevity in your answer.  6.87. In the year 2006, what is the difference between the % of value added in manufacturing in Colombia and % of value added in manufacturing in Turkey?
Keep it short and to the point. 5.9. In the year 2006, what is the difference between the % of value added in manufacturing of Finland and % of value added in manufacturing of Turkey?
Provide a short and direct response. -0.97. In the year 2007, what is the difference between the % of value added in manufacturing of Belgium and % of value added in manufacturing of Colombia?
Make the answer very short. 8.81. In the year 2007, what is the difference between the % of value added in manufacturing in Belgium and % of value added in manufacturing in Finland?
Offer a very short reply. 14.96. In the year 2007, what is the difference between the % of value added in manufacturing of Belgium and % of value added in manufacturing of Turkey?
Offer a very short reply. 14.42. In the year 2007, what is the difference between the % of value added in manufacturing in Colombia and % of value added in manufacturing in Finland?
Your answer should be compact. 6.14. In the year 2007, what is the difference between the % of value added in manufacturing in Colombia and % of value added in manufacturing in Turkey?
Ensure brevity in your answer.  5.61. In the year 2007, what is the difference between the % of value added in manufacturing of Finland and % of value added in manufacturing of Turkey?
Make the answer very short. -0.54. In the year 2008, what is the difference between the % of value added in manufacturing of Belgium and % of value added in manufacturing of Colombia?
Offer a terse response. 8.23. In the year 2008, what is the difference between the % of value added in manufacturing in Belgium and % of value added in manufacturing in Finland?
Your answer should be compact. 14.62. In the year 2008, what is the difference between the % of value added in manufacturing in Belgium and % of value added in manufacturing in Turkey?
Provide a succinct answer. 14.74. In the year 2008, what is the difference between the % of value added in manufacturing of Colombia and % of value added in manufacturing of Finland?
Your answer should be compact. 6.39. In the year 2008, what is the difference between the % of value added in manufacturing of Colombia and % of value added in manufacturing of Turkey?
Your response must be concise. 6.51. In the year 2008, what is the difference between the % of value added in manufacturing of Finland and % of value added in manufacturing of Turkey?
Keep it short and to the point. 0.12. What is the ratio of the % of value added in manufacturing of Belgium in 2000 to that in 2001?
Your response must be concise. 0.98. What is the ratio of the % of value added in manufacturing of Colombia in 2000 to that in 2001?
Ensure brevity in your answer.  1.03. What is the ratio of the % of value added in manufacturing of Finland in 2000 to that in 2001?
Make the answer very short. 0.98. What is the ratio of the % of value added in manufacturing of Turkey in 2000 to that in 2001?
Your answer should be very brief. 0.98. What is the ratio of the % of value added in manufacturing in Belgium in 2000 to that in 2003?
Offer a terse response. 0.96. What is the ratio of the % of value added in manufacturing of Finland in 2000 to that in 2003?
Give a very brief answer. 0.92. What is the ratio of the % of value added in manufacturing of Turkey in 2000 to that in 2003?
Offer a terse response. 1.04. What is the ratio of the % of value added in manufacturing of Belgium in 2000 to that in 2004?
Your answer should be compact. 0.97. What is the ratio of the % of value added in manufacturing in Colombia in 2000 to that in 2004?
Provide a succinct answer. 1.15. What is the ratio of the % of value added in manufacturing of Finland in 2000 to that in 2004?
Provide a succinct answer. 0.8. What is the ratio of the % of value added in manufacturing in Turkey in 2000 to that in 2004?
Make the answer very short. 1.14. What is the ratio of the % of value added in manufacturing of Belgium in 2000 to that in 2005?
Offer a terse response. 0.92. What is the ratio of the % of value added in manufacturing of Colombia in 2000 to that in 2005?
Your response must be concise. 1.22. What is the ratio of the % of value added in manufacturing in Finland in 2000 to that in 2005?
Keep it short and to the point. 0.83. What is the ratio of the % of value added in manufacturing in Turkey in 2000 to that in 2005?
Give a very brief answer. 1.5. What is the ratio of the % of value added in manufacturing in Belgium in 2000 to that in 2006?
Provide a succinct answer. 0.88. What is the ratio of the % of value added in manufacturing in Colombia in 2000 to that in 2006?
Provide a short and direct response. 1.26. What is the ratio of the % of value added in manufacturing of Finland in 2000 to that in 2006?
Ensure brevity in your answer.  0.89. What is the ratio of the % of value added in manufacturing of Turkey in 2000 to that in 2006?
Your response must be concise. 1.48. What is the ratio of the % of value added in manufacturing of Belgium in 2000 to that in 2007?
Your answer should be compact. 0.96. What is the ratio of the % of value added in manufacturing in Colombia in 2000 to that in 2007?
Ensure brevity in your answer.  1.33. What is the ratio of the % of value added in manufacturing of Finland in 2000 to that in 2007?
Provide a succinct answer. 0.88. What is the ratio of the % of value added in manufacturing of Turkey in 2000 to that in 2007?
Make the answer very short. 1.57. What is the ratio of the % of value added in manufacturing in Belgium in 2000 to that in 2008?
Keep it short and to the point. 0.93. What is the ratio of the % of value added in manufacturing in Colombia in 2000 to that in 2008?
Provide a succinct answer. 1.21. What is the ratio of the % of value added in manufacturing of Finland in 2000 to that in 2008?
Offer a terse response. 0.75. What is the ratio of the % of value added in manufacturing in Turkey in 2000 to that in 2008?
Ensure brevity in your answer.  1.49. What is the ratio of the % of value added in manufacturing of Belgium in 2001 to that in 2003?
Make the answer very short. 0.97. What is the ratio of the % of value added in manufacturing of Colombia in 2001 to that in 2003?
Make the answer very short. 1.01. What is the ratio of the % of value added in manufacturing of Finland in 2001 to that in 2003?
Provide a short and direct response. 0.94. What is the ratio of the % of value added in manufacturing of Turkey in 2001 to that in 2003?
Provide a succinct answer. 1.06. What is the ratio of the % of value added in manufacturing in Belgium in 2001 to that in 2004?
Give a very brief answer. 0.98. What is the ratio of the % of value added in manufacturing of Colombia in 2001 to that in 2004?
Make the answer very short. 1.12. What is the ratio of the % of value added in manufacturing of Finland in 2001 to that in 2004?
Provide a succinct answer. 0.82. What is the ratio of the % of value added in manufacturing of Turkey in 2001 to that in 2004?
Ensure brevity in your answer.  1.17. What is the ratio of the % of value added in manufacturing of Belgium in 2001 to that in 2005?
Ensure brevity in your answer.  0.94. What is the ratio of the % of value added in manufacturing in Colombia in 2001 to that in 2005?
Give a very brief answer. 1.19. What is the ratio of the % of value added in manufacturing in Finland in 2001 to that in 2005?
Your answer should be compact. 0.85. What is the ratio of the % of value added in manufacturing in Turkey in 2001 to that in 2005?
Provide a succinct answer. 1.53. What is the ratio of the % of value added in manufacturing in Belgium in 2001 to that in 2006?
Ensure brevity in your answer.  0.9. What is the ratio of the % of value added in manufacturing in Colombia in 2001 to that in 2006?
Offer a terse response. 1.23. What is the ratio of the % of value added in manufacturing of Finland in 2001 to that in 2006?
Provide a short and direct response. 0.91. What is the ratio of the % of value added in manufacturing of Turkey in 2001 to that in 2006?
Provide a short and direct response. 1.51. What is the ratio of the % of value added in manufacturing of Belgium in 2001 to that in 2007?
Offer a terse response. 0.98. What is the ratio of the % of value added in manufacturing of Colombia in 2001 to that in 2007?
Ensure brevity in your answer.  1.3. What is the ratio of the % of value added in manufacturing in Finland in 2001 to that in 2007?
Your answer should be compact. 0.9. What is the ratio of the % of value added in manufacturing in Turkey in 2001 to that in 2007?
Offer a terse response. 1.6. What is the ratio of the % of value added in manufacturing of Belgium in 2001 to that in 2008?
Ensure brevity in your answer.  0.95. What is the ratio of the % of value added in manufacturing of Colombia in 2001 to that in 2008?
Offer a very short reply. 1.18. What is the ratio of the % of value added in manufacturing in Finland in 2001 to that in 2008?
Your answer should be compact. 0.77. What is the ratio of the % of value added in manufacturing in Turkey in 2001 to that in 2008?
Your answer should be compact. 1.53. What is the ratio of the % of value added in manufacturing of Belgium in 2003 to that in 2004?
Ensure brevity in your answer.  1.01. What is the ratio of the % of value added in manufacturing in Colombia in 2003 to that in 2004?
Your response must be concise. 1.11. What is the ratio of the % of value added in manufacturing in Finland in 2003 to that in 2004?
Give a very brief answer. 0.88. What is the ratio of the % of value added in manufacturing of Turkey in 2003 to that in 2004?
Keep it short and to the point. 1.1. What is the ratio of the % of value added in manufacturing in Belgium in 2003 to that in 2005?
Ensure brevity in your answer.  0.96. What is the ratio of the % of value added in manufacturing in Colombia in 2003 to that in 2005?
Ensure brevity in your answer.  1.18. What is the ratio of the % of value added in manufacturing of Finland in 2003 to that in 2005?
Offer a terse response. 0.9. What is the ratio of the % of value added in manufacturing of Turkey in 2003 to that in 2005?
Provide a short and direct response. 1.44. What is the ratio of the % of value added in manufacturing in Belgium in 2003 to that in 2006?
Your answer should be compact. 0.92. What is the ratio of the % of value added in manufacturing of Colombia in 2003 to that in 2006?
Your answer should be very brief. 1.22. What is the ratio of the % of value added in manufacturing of Finland in 2003 to that in 2006?
Keep it short and to the point. 0.96. What is the ratio of the % of value added in manufacturing of Turkey in 2003 to that in 2006?
Provide a succinct answer. 1.42. What is the ratio of the % of value added in manufacturing in Belgium in 2003 to that in 2007?
Give a very brief answer. 1.01. What is the ratio of the % of value added in manufacturing in Colombia in 2003 to that in 2007?
Offer a terse response. 1.28. What is the ratio of the % of value added in manufacturing of Finland in 2003 to that in 2007?
Ensure brevity in your answer.  0.96. What is the ratio of the % of value added in manufacturing of Turkey in 2003 to that in 2007?
Make the answer very short. 1.51. What is the ratio of the % of value added in manufacturing of Belgium in 2003 to that in 2008?
Give a very brief answer. 0.98. What is the ratio of the % of value added in manufacturing of Finland in 2003 to that in 2008?
Provide a short and direct response. 0.82. What is the ratio of the % of value added in manufacturing in Turkey in 2003 to that in 2008?
Provide a succinct answer. 1.44. What is the ratio of the % of value added in manufacturing in Belgium in 2004 to that in 2005?
Your answer should be very brief. 0.95. What is the ratio of the % of value added in manufacturing of Colombia in 2004 to that in 2005?
Ensure brevity in your answer.  1.06. What is the ratio of the % of value added in manufacturing of Finland in 2004 to that in 2005?
Make the answer very short. 1.03. What is the ratio of the % of value added in manufacturing in Turkey in 2004 to that in 2005?
Offer a very short reply. 1.31. What is the ratio of the % of value added in manufacturing in Belgium in 2004 to that in 2006?
Give a very brief answer. 0.91. What is the ratio of the % of value added in manufacturing of Colombia in 2004 to that in 2006?
Your answer should be compact. 1.1. What is the ratio of the % of value added in manufacturing in Finland in 2004 to that in 2006?
Ensure brevity in your answer.  1.1. What is the ratio of the % of value added in manufacturing of Turkey in 2004 to that in 2006?
Offer a terse response. 1.3. What is the ratio of the % of value added in manufacturing of Belgium in 2004 to that in 2007?
Give a very brief answer. 1. What is the ratio of the % of value added in manufacturing in Colombia in 2004 to that in 2007?
Offer a very short reply. 1.16. What is the ratio of the % of value added in manufacturing of Finland in 2004 to that in 2007?
Keep it short and to the point. 1.09. What is the ratio of the % of value added in manufacturing of Turkey in 2004 to that in 2007?
Offer a very short reply. 1.37. What is the ratio of the % of value added in manufacturing of Belgium in 2004 to that in 2008?
Make the answer very short. 0.97. What is the ratio of the % of value added in manufacturing of Colombia in 2004 to that in 2008?
Provide a short and direct response. 1.05. What is the ratio of the % of value added in manufacturing in Finland in 2004 to that in 2008?
Provide a succinct answer. 0.94. What is the ratio of the % of value added in manufacturing in Turkey in 2004 to that in 2008?
Your answer should be compact. 1.31. What is the ratio of the % of value added in manufacturing in Belgium in 2005 to that in 2006?
Ensure brevity in your answer.  0.96. What is the ratio of the % of value added in manufacturing in Colombia in 2005 to that in 2006?
Give a very brief answer. 1.03. What is the ratio of the % of value added in manufacturing of Finland in 2005 to that in 2006?
Ensure brevity in your answer.  1.07. What is the ratio of the % of value added in manufacturing of Turkey in 2005 to that in 2006?
Provide a succinct answer. 0.99. What is the ratio of the % of value added in manufacturing in Belgium in 2005 to that in 2007?
Provide a succinct answer. 1.05. What is the ratio of the % of value added in manufacturing of Colombia in 2005 to that in 2007?
Make the answer very short. 1.09. What is the ratio of the % of value added in manufacturing of Finland in 2005 to that in 2007?
Offer a terse response. 1.06. What is the ratio of the % of value added in manufacturing of Turkey in 2005 to that in 2007?
Make the answer very short. 1.05. What is the ratio of the % of value added in manufacturing in Belgium in 2005 to that in 2008?
Your answer should be very brief. 1.02. What is the ratio of the % of value added in manufacturing of Colombia in 2005 to that in 2008?
Keep it short and to the point. 0.99. What is the ratio of the % of value added in manufacturing of Finland in 2005 to that in 2008?
Your answer should be very brief. 0.91. What is the ratio of the % of value added in manufacturing in Turkey in 2005 to that in 2008?
Offer a very short reply. 1. What is the ratio of the % of value added in manufacturing in Belgium in 2006 to that in 2007?
Ensure brevity in your answer.  1.09. What is the ratio of the % of value added in manufacturing in Colombia in 2006 to that in 2007?
Your response must be concise. 1.06. What is the ratio of the % of value added in manufacturing in Finland in 2006 to that in 2007?
Your response must be concise. 0.99. What is the ratio of the % of value added in manufacturing of Turkey in 2006 to that in 2007?
Provide a succinct answer. 1.06. What is the ratio of the % of value added in manufacturing in Belgium in 2006 to that in 2008?
Provide a short and direct response. 1.06. What is the ratio of the % of value added in manufacturing in Colombia in 2006 to that in 2008?
Your answer should be compact. 0.96. What is the ratio of the % of value added in manufacturing of Finland in 2006 to that in 2008?
Keep it short and to the point. 0.85. What is the ratio of the % of value added in manufacturing of Turkey in 2006 to that in 2008?
Your response must be concise. 1.01. What is the ratio of the % of value added in manufacturing of Belgium in 2007 to that in 2008?
Ensure brevity in your answer.  0.97. What is the ratio of the % of value added in manufacturing in Colombia in 2007 to that in 2008?
Make the answer very short. 0.91. What is the ratio of the % of value added in manufacturing of Finland in 2007 to that in 2008?
Provide a succinct answer. 0.86. What is the ratio of the % of value added in manufacturing in Turkey in 2007 to that in 2008?
Provide a short and direct response. 0.95. What is the difference between the highest and the second highest % of value added in manufacturing of Belgium?
Your answer should be compact. 0.92. What is the difference between the highest and the second highest % of value added in manufacturing in Colombia?
Give a very brief answer. 0.42. What is the difference between the highest and the second highest % of value added in manufacturing in Finland?
Offer a very short reply. 0.42. What is the difference between the highest and the second highest % of value added in manufacturing of Turkey?
Keep it short and to the point. 0.23. What is the difference between the highest and the lowest % of value added in manufacturing of Belgium?
Your answer should be compact. 2.68. What is the difference between the highest and the lowest % of value added in manufacturing of Colombia?
Your answer should be very brief. 4.02. What is the difference between the highest and the lowest % of value added in manufacturing in Finland?
Your answer should be compact. 1.69. What is the difference between the highest and the lowest % of value added in manufacturing of Turkey?
Give a very brief answer. 3.87. 